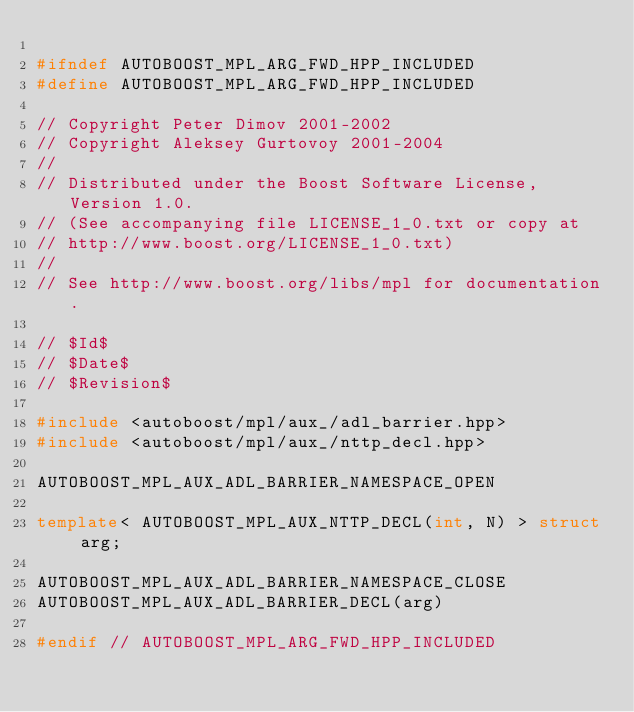Convert code to text. <code><loc_0><loc_0><loc_500><loc_500><_C++_>
#ifndef AUTOBOOST_MPL_ARG_FWD_HPP_INCLUDED
#define AUTOBOOST_MPL_ARG_FWD_HPP_INCLUDED

// Copyright Peter Dimov 2001-2002
// Copyright Aleksey Gurtovoy 2001-2004
//
// Distributed under the Boost Software License, Version 1.0.
// (See accompanying file LICENSE_1_0.txt or copy at
// http://www.boost.org/LICENSE_1_0.txt)
//
// See http://www.boost.org/libs/mpl for documentation.

// $Id$
// $Date$
// $Revision$

#include <autoboost/mpl/aux_/adl_barrier.hpp>
#include <autoboost/mpl/aux_/nttp_decl.hpp>

AUTOBOOST_MPL_AUX_ADL_BARRIER_NAMESPACE_OPEN

template< AUTOBOOST_MPL_AUX_NTTP_DECL(int, N) > struct arg;

AUTOBOOST_MPL_AUX_ADL_BARRIER_NAMESPACE_CLOSE
AUTOBOOST_MPL_AUX_ADL_BARRIER_DECL(arg)

#endif // AUTOBOOST_MPL_ARG_FWD_HPP_INCLUDED
</code> 